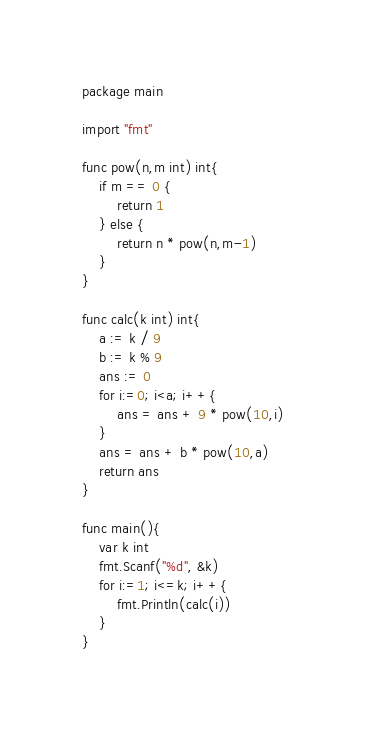Convert code to text. <code><loc_0><loc_0><loc_500><loc_500><_Go_>package main

import "fmt"

func pow(n,m int) int{
	if m == 0 {
		return 1
	} else {
		return n * pow(n,m-1)
	}
}

func calc(k int) int{
	a := k / 9
	b := k % 9
	ans := 0
	for i:=0; i<a; i++{
		ans = ans + 9 * pow(10,i)
	}
	ans = ans + b * pow(10,a)
	return ans
}

func main(){
	var k int
	fmt.Scanf("%d", &k)
	for i:=1; i<=k; i++{
		fmt.Println(calc(i))
	}
}
</code> 